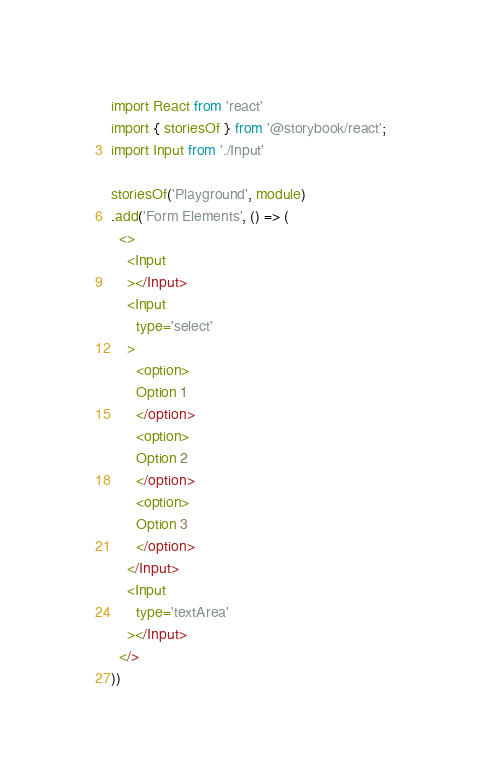Convert code to text. <code><loc_0><loc_0><loc_500><loc_500><_JavaScript_>import React from 'react'
import { storiesOf } from '@storybook/react';
import Input from './Input'

storiesOf('Playground', module)
.add('Form Elements', () => (
  <>
    <Input
    ></Input>
    <Input
      type='select'
    >
      <option>
      Option 1
      </option>
      <option>
      Option 2
      </option>
      <option>
      Option 3
      </option>
    </Input>
    <Input
      type='textArea'
    ></Input>
  </>
))</code> 